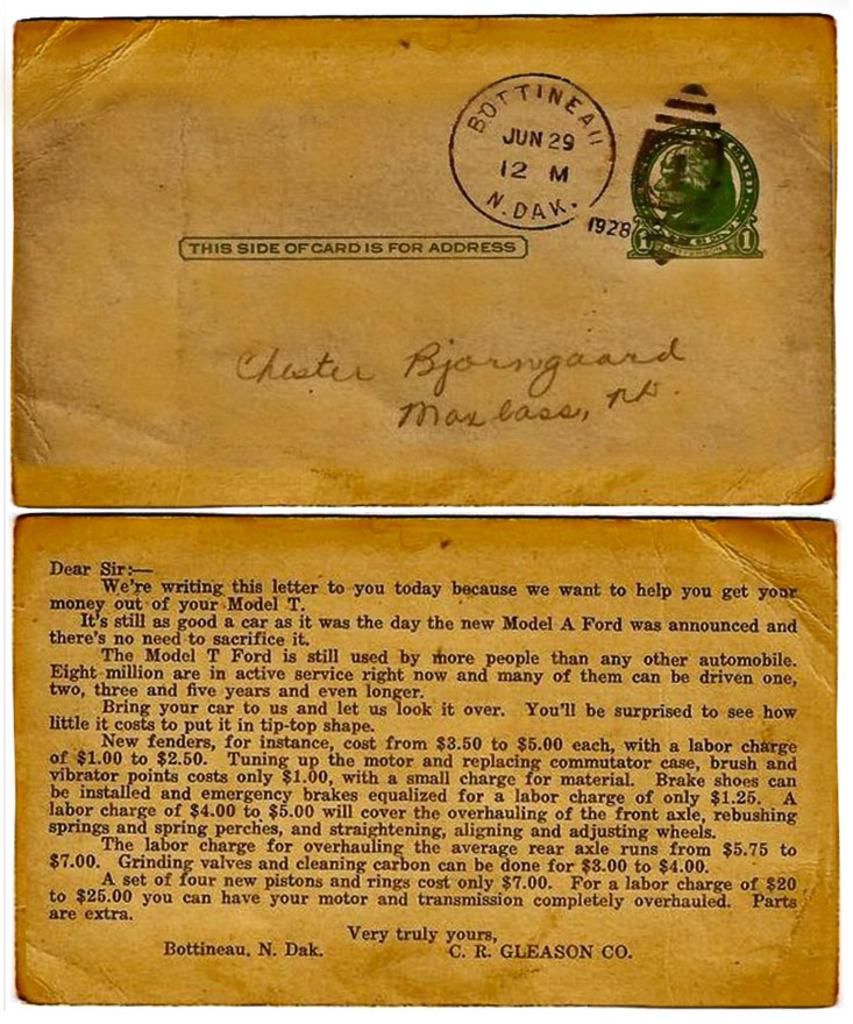<image>
Share a concise interpretation of the image provided. A follow up letter from the Ford Corporation is mailed to a North Dakota address. 